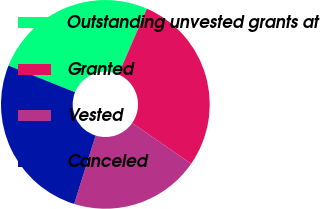Convert chart. <chart><loc_0><loc_0><loc_500><loc_500><pie_chart><fcel>Outstanding unvested grants at<fcel>Granted<fcel>Vested<fcel>Canceled<nl><fcel>25.45%<fcel>28.13%<fcel>20.18%<fcel>26.24%<nl></chart> 